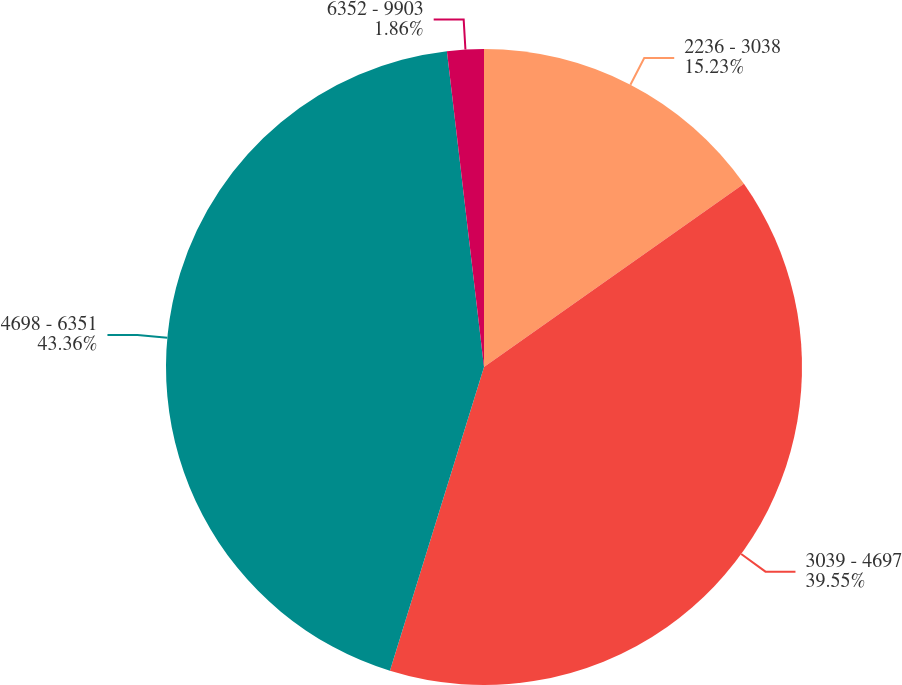Convert chart to OTSL. <chart><loc_0><loc_0><loc_500><loc_500><pie_chart><fcel>2236 - 3038<fcel>3039 - 4697<fcel>4698 - 6351<fcel>6352 - 9903<nl><fcel>15.23%<fcel>39.55%<fcel>43.36%<fcel>1.86%<nl></chart> 